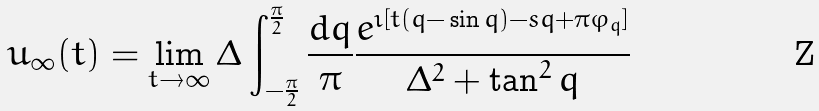Convert formula to latex. <formula><loc_0><loc_0><loc_500><loc_500>u _ { \infty } ( t ) = \lim _ { t \to \infty } \Delta \int _ { - \frac { \pi } { 2 } } ^ { \frac { \pi } { 2 } } \frac { d q } \pi \frac { e ^ { \imath [ t ( q { - } \sin q ) - s q + \pi \varphi _ { q } ] } } { \Delta ^ { 2 } + \tan ^ { 2 } q }</formula> 